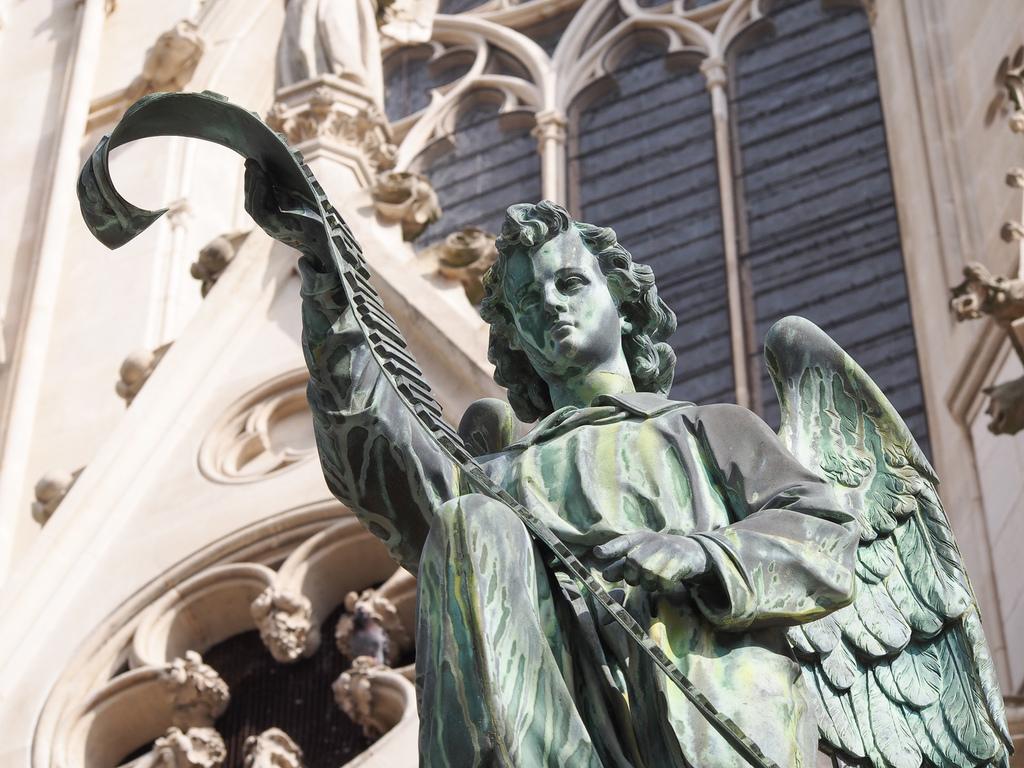Please provide a concise description of this image. In the picture I can see sculpture of a person. In the background I can see a building which has art designs on it. 